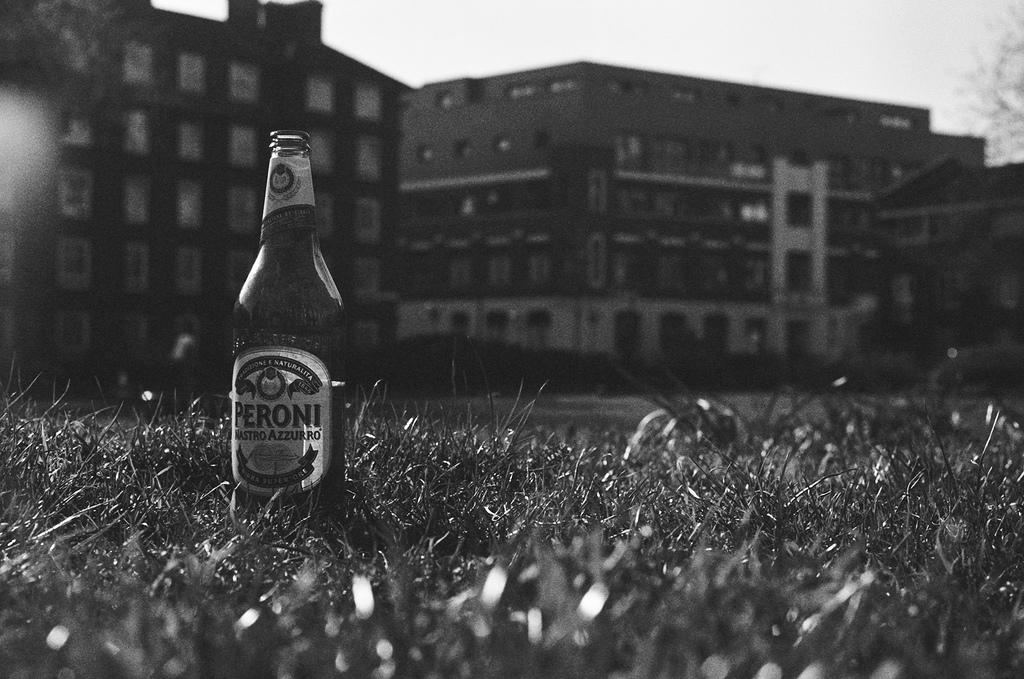What object is located on the left side of the image? There is a bottle on the left side of the image. What type of natural environment is visible at the bottom of the image? There is grass at the bottom of the image. What can be seen in the background of the image? There is a building and the sky visible in the background of the image. What type of basketball court can be seen in the image? There is no basketball court present in the image. What type of polish is being applied to the building in the image? There is no polish or indication of any maintenance work being done on the building in the image. 